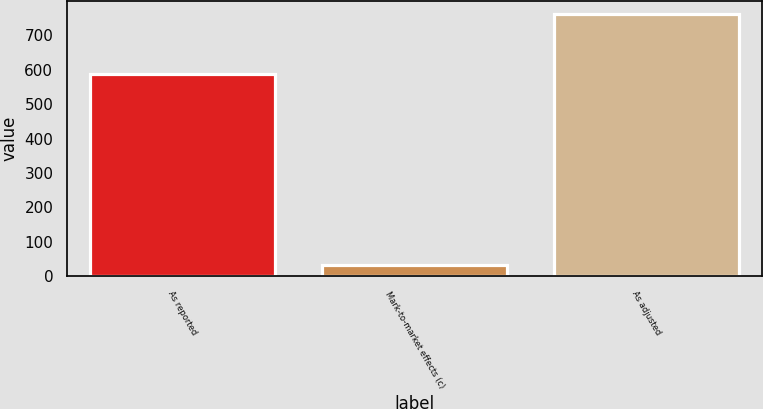<chart> <loc_0><loc_0><loc_500><loc_500><bar_chart><fcel>As reported<fcel>Mark-to-market effects (c)<fcel>As adjusted<nl><fcel>586.8<fcel>33.2<fcel>760.8<nl></chart> 